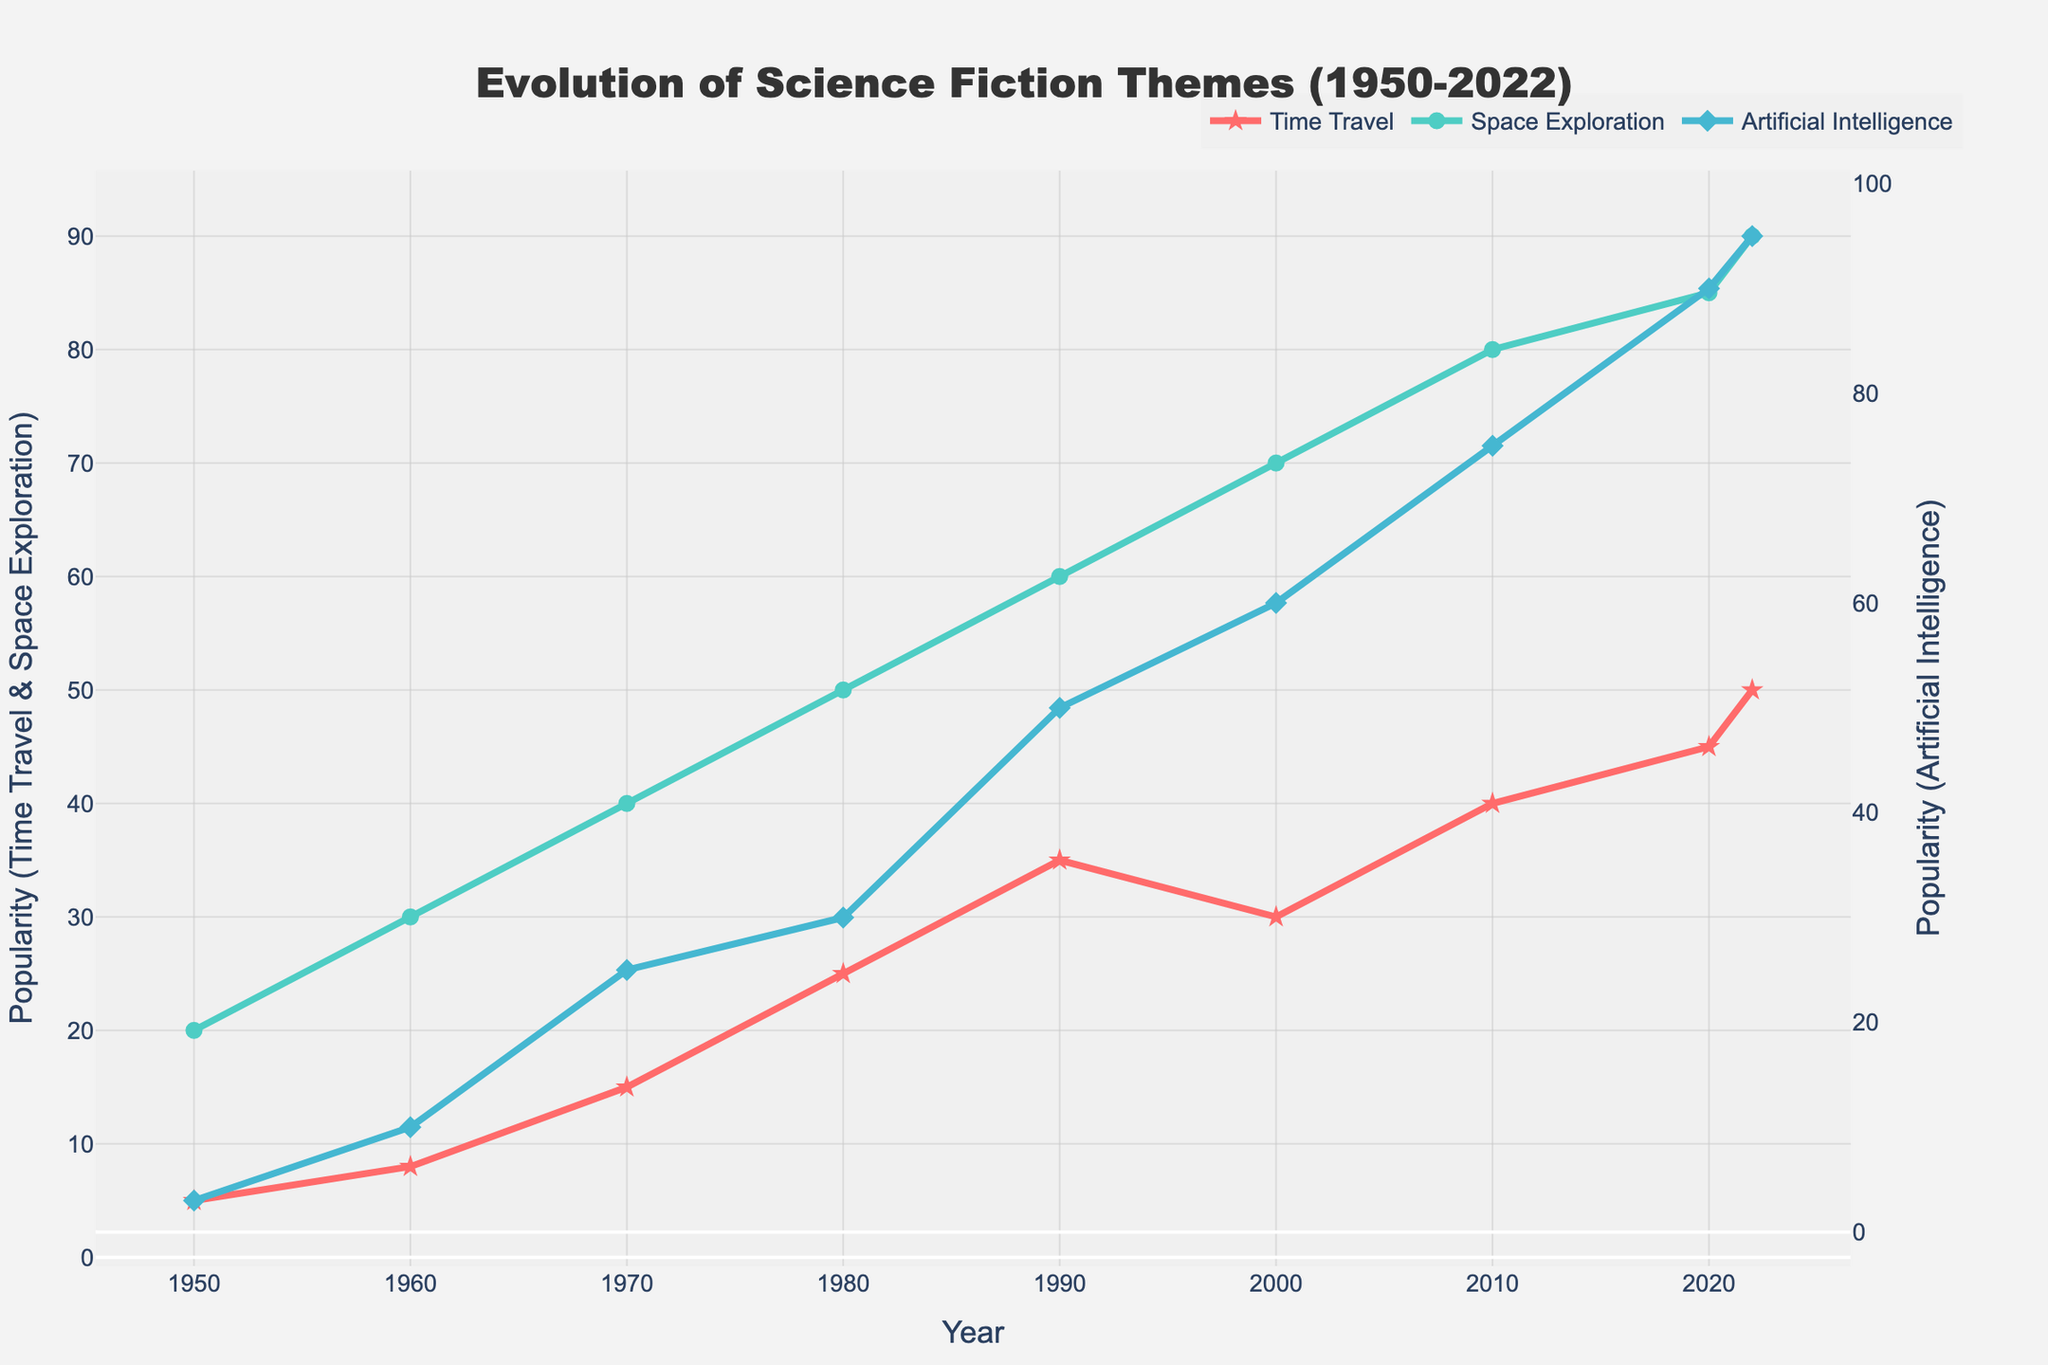what is the title of the figure? The title can be found at the top center of the figure and it states the main purpose and scope of the plot. It reads: "Evolution of Science Fiction Themes (1950-2022)"
Answer: Evolution of Science Fiction Themes (1950-2022) Which theme had the highest popularity in 2022? To determine the highest popularity in 2022, look at the end points of the three lines for that year. The Artificial Intelligence theme has the highest value.
Answer: Artificial Intelligence How did the popularity of Time Travel change from 1960 to 1980? To find this, locate the values for Time Travel in the years 1960 and 1980, and calculate the difference. In 1960, the value was 8, while in 1980, it increased to 25.
Answer: Increased by 17 Which science fiction theme saw the biggest increase in popularity between 2010 and 2020? To determine this, compare the difference in popularity for each theme between 2010 and 2020. Time Travel increased from 40 to 45 (+5), Space Exploration from 80 to 85 (+5), and Artificial Intelligence from 75 to 90 (+15).
Answer: Artificial Intelligence In which decade did Space Exploration experience its largest jump in popularity? To find the largest jump, compare the increases each decade. The biggest change is between 1950-1960 (+10), 1960-1970 (+10), 1970-1980 (+10), 1980-1990 (+10), 1990-2000 (+10), 2000-2010 (+10), and 2010-2020 (+5).
Answer: 1990-2000 What is the average popularity of Artificial Intelligence from 1950 to 2022? To find the average, sum the popularity values for Artificial Intelligence for each year presented and divide by the number of years. The values are: 3, 10, 25, 30, 50, 60, 75, 90, 95. Sum is 438, and there are 9 values, so the average is 438/9.
Answer: 48.67 How many years did Space Exploration lead in popularity compared to the other themes? To determine this, identify the years in which the popularity value of Space Exploration was higher than Time Travel and Artificial Intelligence. From the plot, Space Exploration leads in all years from 1950 to 2022.
Answer: 9 years What is the trend of Time Travel theme from 1950 to 2022? Observing the line representing Time Travel across the years 1950 to 2022, it generally shows a steady increase in popularity, without any significant drops.
Answer: Increasing trend 